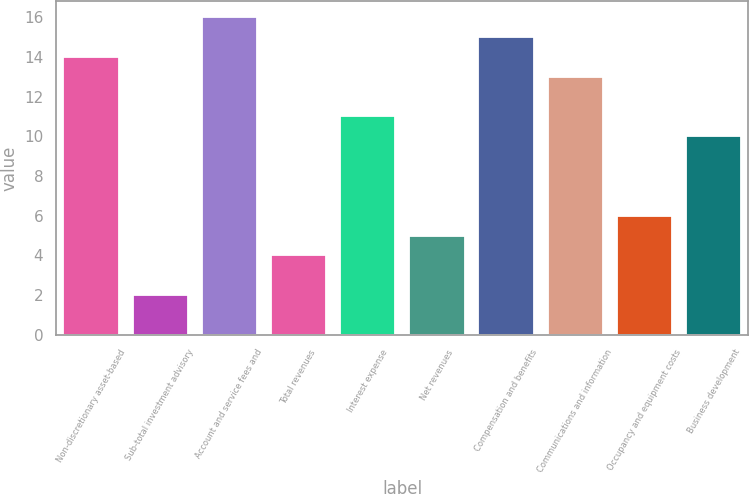Convert chart. <chart><loc_0><loc_0><loc_500><loc_500><bar_chart><fcel>Non-discretionary asset-based<fcel>Sub-total investment advisory<fcel>Account and service fees and<fcel>Total revenues<fcel>Interest expense<fcel>Net revenues<fcel>Compensation and benefits<fcel>Communications and information<fcel>Occupancy and equipment costs<fcel>Business development<nl><fcel>14<fcel>2<fcel>16<fcel>4<fcel>11<fcel>5<fcel>15<fcel>13<fcel>6<fcel>10<nl></chart> 